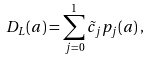Convert formula to latex. <formula><loc_0><loc_0><loc_500><loc_500>D _ { L } ( a ) = \sum _ { j = 0 } ^ { 1 } \tilde { c } _ { j } p _ { j } ( a ) \, ,</formula> 